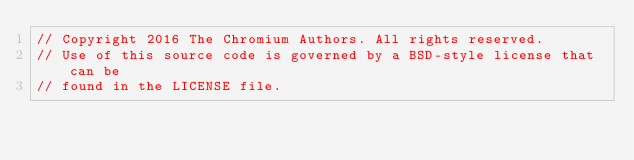<code> <loc_0><loc_0><loc_500><loc_500><_ObjectiveC_>// Copyright 2016 The Chromium Authors. All rights reserved.
// Use of this source code is governed by a BSD-style license that can be
// found in the LICENSE file.
</code> 